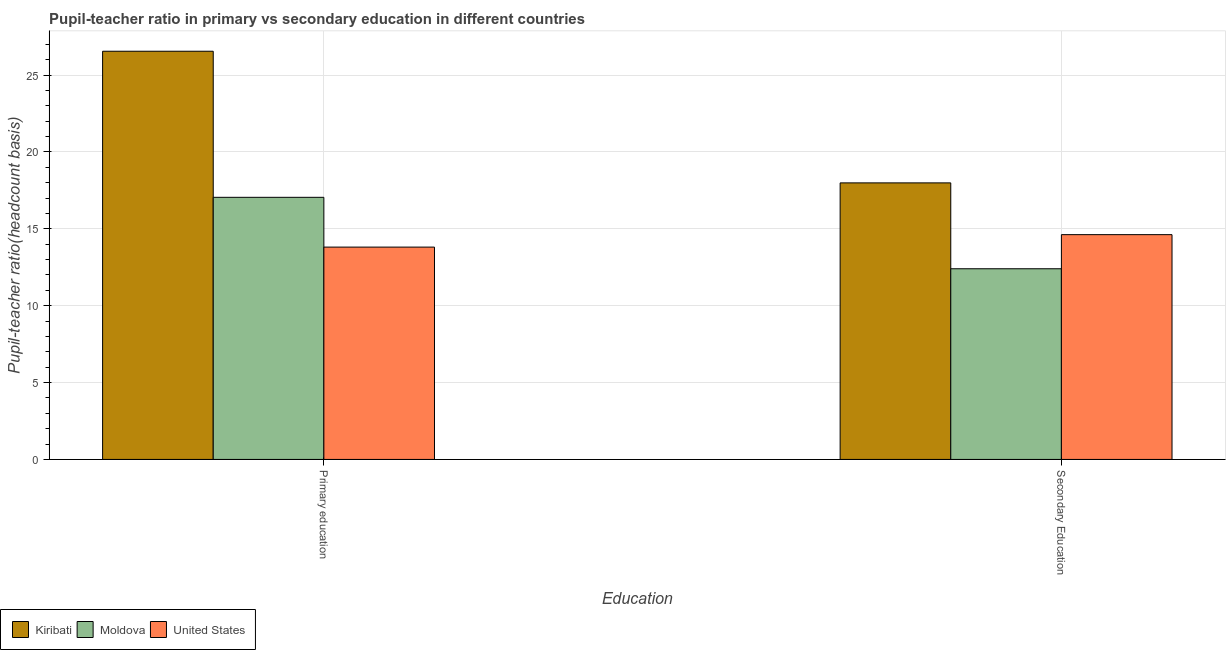How many different coloured bars are there?
Your answer should be compact. 3. How many groups of bars are there?
Your response must be concise. 2. How many bars are there on the 1st tick from the right?
Provide a short and direct response. 3. What is the label of the 2nd group of bars from the left?
Make the answer very short. Secondary Education. What is the pupil-teacher ratio in primary education in Moldova?
Your response must be concise. 17.05. Across all countries, what is the maximum pupil teacher ratio on secondary education?
Offer a very short reply. 17.98. Across all countries, what is the minimum pupil-teacher ratio in primary education?
Your answer should be very brief. 13.81. In which country was the pupil teacher ratio on secondary education maximum?
Provide a succinct answer. Kiribati. What is the total pupil teacher ratio on secondary education in the graph?
Ensure brevity in your answer.  45. What is the difference between the pupil-teacher ratio in primary education in Moldova and that in United States?
Make the answer very short. 3.24. What is the difference between the pupil teacher ratio on secondary education in United States and the pupil-teacher ratio in primary education in Moldova?
Give a very brief answer. -2.43. What is the average pupil teacher ratio on secondary education per country?
Ensure brevity in your answer.  15. What is the difference between the pupil teacher ratio on secondary education and pupil-teacher ratio in primary education in Kiribati?
Offer a terse response. -8.56. In how many countries, is the pupil-teacher ratio in primary education greater than 25 ?
Your answer should be very brief. 1. What is the ratio of the pupil teacher ratio on secondary education in United States to that in Kiribati?
Ensure brevity in your answer.  0.81. What does the 2nd bar from the left in Primary education represents?
Ensure brevity in your answer.  Moldova. What does the 3rd bar from the right in Secondary Education represents?
Give a very brief answer. Kiribati. How many bars are there?
Offer a very short reply. 6. Are all the bars in the graph horizontal?
Your response must be concise. No. Does the graph contain any zero values?
Your response must be concise. No. Does the graph contain grids?
Your answer should be compact. Yes. What is the title of the graph?
Offer a very short reply. Pupil-teacher ratio in primary vs secondary education in different countries. What is the label or title of the X-axis?
Give a very brief answer. Education. What is the label or title of the Y-axis?
Offer a terse response. Pupil-teacher ratio(headcount basis). What is the Pupil-teacher ratio(headcount basis) in Kiribati in Primary education?
Your answer should be compact. 26.55. What is the Pupil-teacher ratio(headcount basis) in Moldova in Primary education?
Offer a terse response. 17.05. What is the Pupil-teacher ratio(headcount basis) of United States in Primary education?
Your response must be concise. 13.81. What is the Pupil-teacher ratio(headcount basis) in Kiribati in Secondary Education?
Your answer should be compact. 17.98. What is the Pupil-teacher ratio(headcount basis) in Moldova in Secondary Education?
Your answer should be very brief. 12.4. What is the Pupil-teacher ratio(headcount basis) of United States in Secondary Education?
Your response must be concise. 14.62. Across all Education, what is the maximum Pupil-teacher ratio(headcount basis) of Kiribati?
Provide a short and direct response. 26.55. Across all Education, what is the maximum Pupil-teacher ratio(headcount basis) of Moldova?
Your answer should be very brief. 17.05. Across all Education, what is the maximum Pupil-teacher ratio(headcount basis) in United States?
Provide a succinct answer. 14.62. Across all Education, what is the minimum Pupil-teacher ratio(headcount basis) in Kiribati?
Your response must be concise. 17.98. Across all Education, what is the minimum Pupil-teacher ratio(headcount basis) in Moldova?
Give a very brief answer. 12.4. Across all Education, what is the minimum Pupil-teacher ratio(headcount basis) of United States?
Offer a very short reply. 13.81. What is the total Pupil-teacher ratio(headcount basis) in Kiribati in the graph?
Give a very brief answer. 44.53. What is the total Pupil-teacher ratio(headcount basis) of Moldova in the graph?
Make the answer very short. 29.45. What is the total Pupil-teacher ratio(headcount basis) in United States in the graph?
Provide a short and direct response. 28.43. What is the difference between the Pupil-teacher ratio(headcount basis) in Kiribati in Primary education and that in Secondary Education?
Your response must be concise. 8.56. What is the difference between the Pupil-teacher ratio(headcount basis) of Moldova in Primary education and that in Secondary Education?
Your answer should be very brief. 4.65. What is the difference between the Pupil-teacher ratio(headcount basis) in United States in Primary education and that in Secondary Education?
Offer a terse response. -0.81. What is the difference between the Pupil-teacher ratio(headcount basis) in Kiribati in Primary education and the Pupil-teacher ratio(headcount basis) in Moldova in Secondary Education?
Make the answer very short. 14.15. What is the difference between the Pupil-teacher ratio(headcount basis) in Kiribati in Primary education and the Pupil-teacher ratio(headcount basis) in United States in Secondary Education?
Give a very brief answer. 11.93. What is the difference between the Pupil-teacher ratio(headcount basis) of Moldova in Primary education and the Pupil-teacher ratio(headcount basis) of United States in Secondary Education?
Make the answer very short. 2.43. What is the average Pupil-teacher ratio(headcount basis) of Kiribati per Education?
Make the answer very short. 22.27. What is the average Pupil-teacher ratio(headcount basis) in Moldova per Education?
Your response must be concise. 14.72. What is the average Pupil-teacher ratio(headcount basis) of United States per Education?
Provide a short and direct response. 14.21. What is the difference between the Pupil-teacher ratio(headcount basis) of Kiribati and Pupil-teacher ratio(headcount basis) of United States in Primary education?
Provide a short and direct response. 12.74. What is the difference between the Pupil-teacher ratio(headcount basis) of Moldova and Pupil-teacher ratio(headcount basis) of United States in Primary education?
Your answer should be very brief. 3.24. What is the difference between the Pupil-teacher ratio(headcount basis) of Kiribati and Pupil-teacher ratio(headcount basis) of Moldova in Secondary Education?
Give a very brief answer. 5.58. What is the difference between the Pupil-teacher ratio(headcount basis) of Kiribati and Pupil-teacher ratio(headcount basis) of United States in Secondary Education?
Your answer should be compact. 3.37. What is the difference between the Pupil-teacher ratio(headcount basis) in Moldova and Pupil-teacher ratio(headcount basis) in United States in Secondary Education?
Ensure brevity in your answer.  -2.22. What is the ratio of the Pupil-teacher ratio(headcount basis) of Kiribati in Primary education to that in Secondary Education?
Offer a very short reply. 1.48. What is the ratio of the Pupil-teacher ratio(headcount basis) of Moldova in Primary education to that in Secondary Education?
Ensure brevity in your answer.  1.37. What is the ratio of the Pupil-teacher ratio(headcount basis) of United States in Primary education to that in Secondary Education?
Keep it short and to the point. 0.94. What is the difference between the highest and the second highest Pupil-teacher ratio(headcount basis) in Kiribati?
Keep it short and to the point. 8.56. What is the difference between the highest and the second highest Pupil-teacher ratio(headcount basis) of Moldova?
Offer a terse response. 4.65. What is the difference between the highest and the second highest Pupil-teacher ratio(headcount basis) of United States?
Your response must be concise. 0.81. What is the difference between the highest and the lowest Pupil-teacher ratio(headcount basis) in Kiribati?
Keep it short and to the point. 8.56. What is the difference between the highest and the lowest Pupil-teacher ratio(headcount basis) of Moldova?
Offer a terse response. 4.65. What is the difference between the highest and the lowest Pupil-teacher ratio(headcount basis) in United States?
Your answer should be very brief. 0.81. 